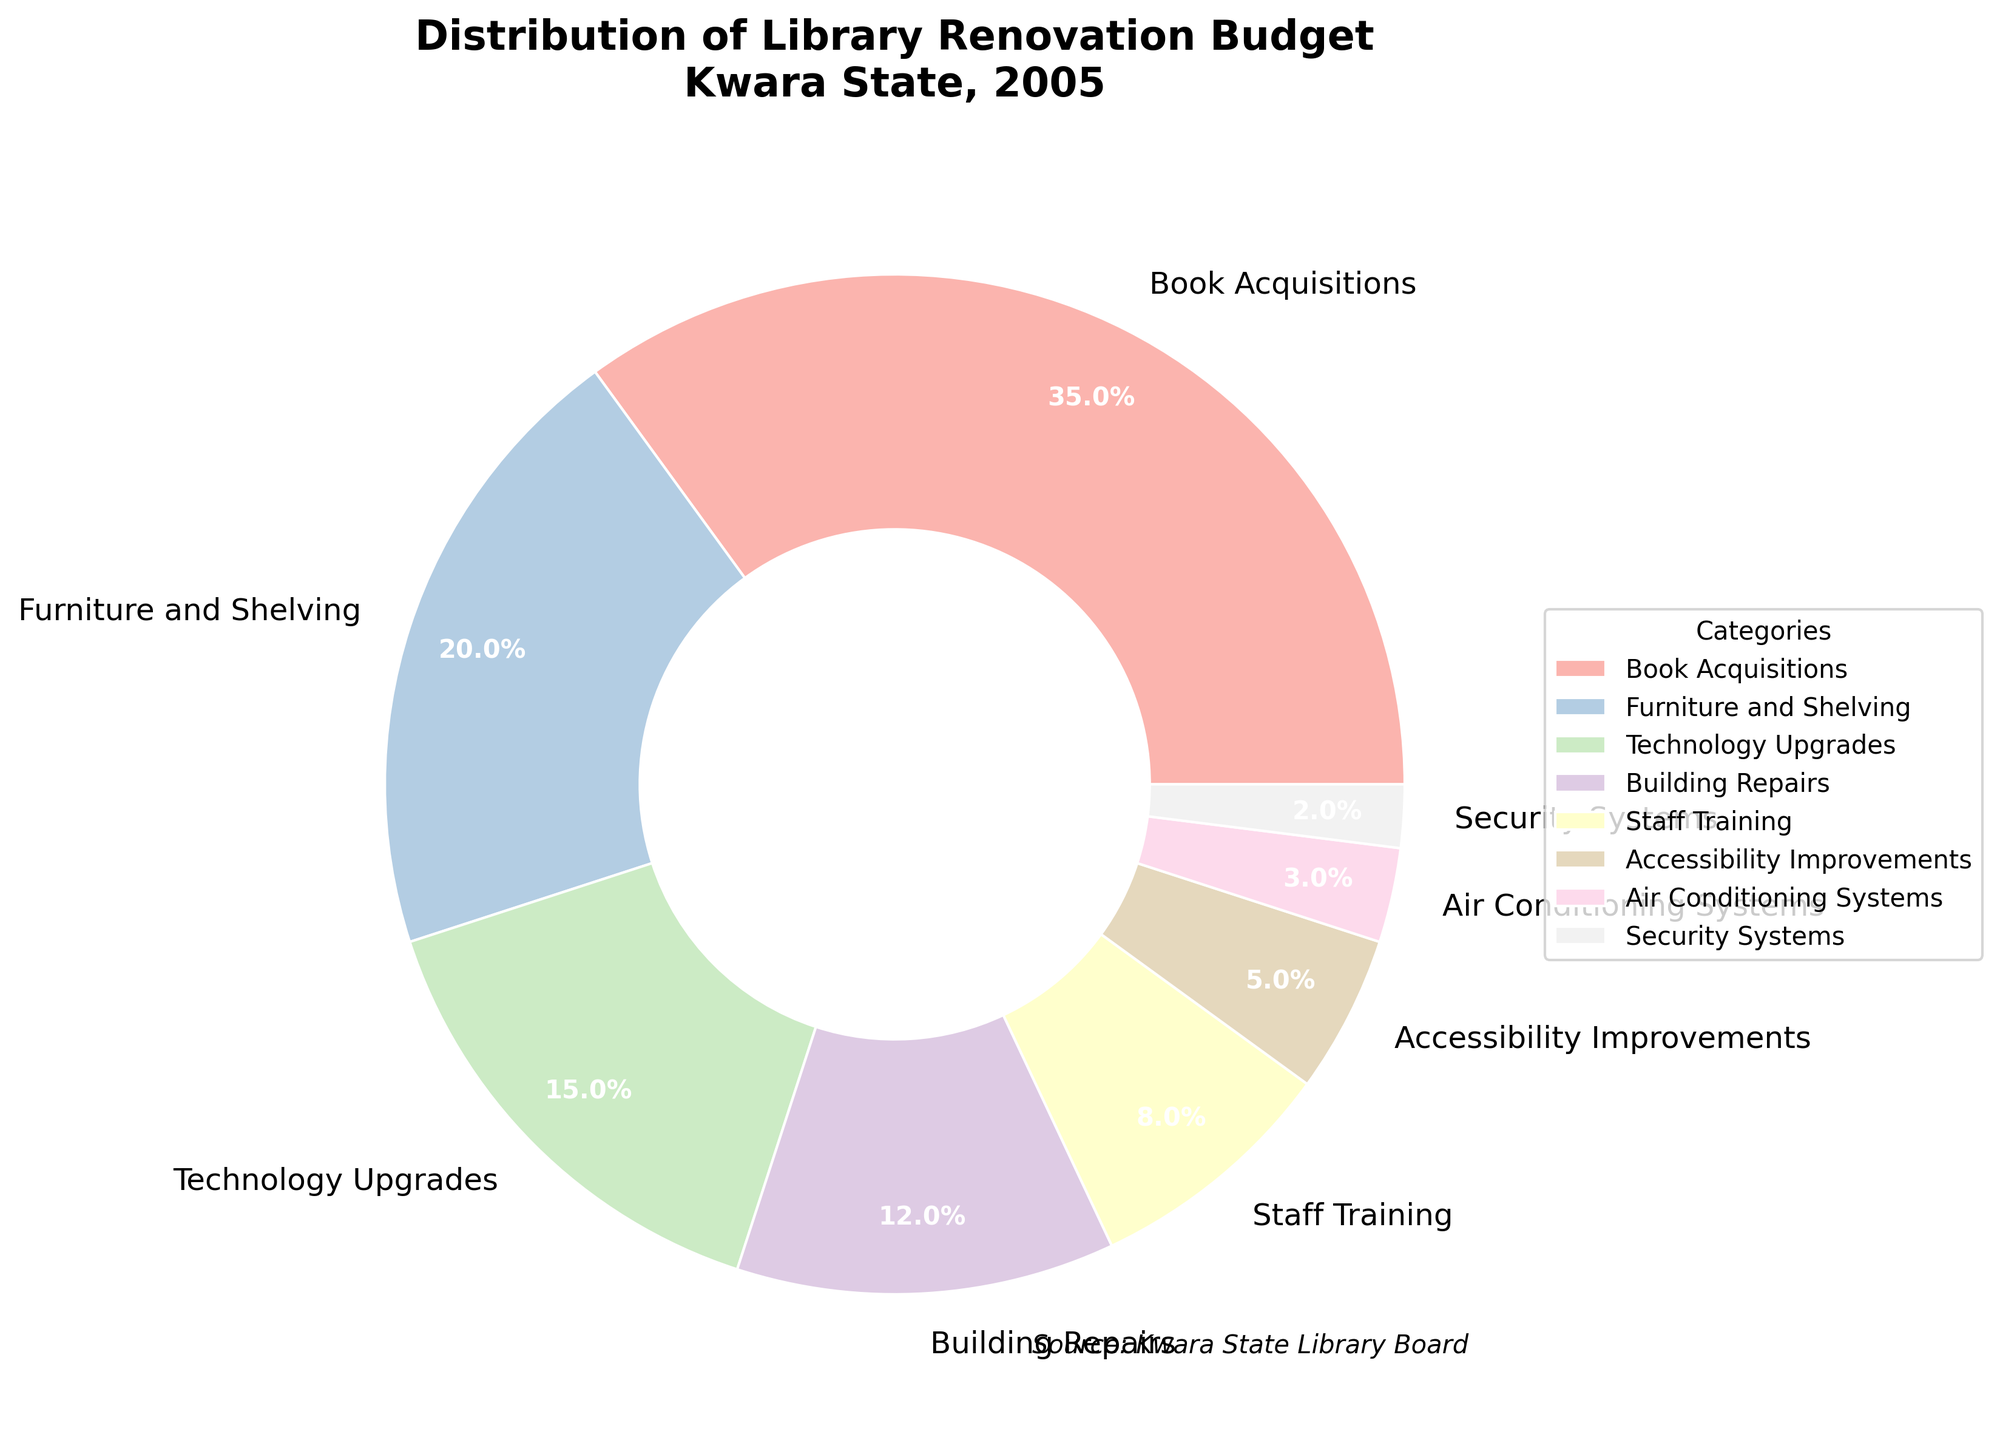What percentage of the budget was allocated to Book Acquisitions? From the pie chart, we see that the section labeled "Book Acquisitions" has a percentage value. Directly checking, we see it shows 35%.
Answer: 35% Which category received the smallest allocation? By looking at the pie chart, find the smallest wedge. The "Security Systems" wedge looks the smallest, marked at 2%.
Answer: Security Systems What is the combined budget percentage of Accessibility Improvements and Air Conditioning Systems? Find the percentages of Accessibility Improvements (5%) and Air Conditioning Systems (3%) from the chart. Add these values: 5% + 3% = 8%.
Answer: 8% Which category received more funding, Technology Upgrades or Furniture and Shelving? Identify the two wedges. Technology Upgrades is 15%, and Furniture and Shelving is 20%. Since 20% > 15%, Furniture and Shelving received more funding.
Answer: Furniture and Shelving What is the total budget percentage allocated to Staff Training and Building Repairs? Retrieve the percentages for Staff Training (8%) and Building Repairs (12%). Add them together: 8% + 12% = 20%.
Answer: 20% Are there more categories with less than 10% allocation or more than 10% allocation? Review the chart and count categories less than 10%: Accessibility Improvements, Air Conditioning Systems, and Security Systems (3). Count categories with more than 10%: Book Acquisitions, Furniture and Shelving, Technology Upgrades, Building Repairs, Staff Training (5). There are more categories with more than 10% allocation.
Answer: More than 10% Compare the allocations for Furniture and Shelving and Book Acquisitions. How much higher is Book Acquisitions? Check the values for both categories. Book Acquisitions is 35% and Furniture and Shelving is 20%. Calculate the difference: 35% - 20% = 15%.
Answer: 15% What is the combined percentage of the top three categories? Identify the top three categories by their allocations: Book Acquisitions (35%), Furniture and Shelving (20%), and Technology Upgrades (15%). Sum these percentages: 35% + 20% + 15% = 70%.
Answer: 70% If the total budget is 1,000,000 NGN, what is the budget amount for Accessibility Improvements? Accessibility Improvements have 5% allocation. Calculate 5% of 1,000,000 NGN: (5/100) * 1,000,000 = 50,000 NGN.
Answer: 50,000 NGN Which category is represented by the thickest wedge? The thickest wedge visually represents the largest allocation. In the chart, the thickest wedge is "Book Acquisitions" at 35%.
Answer: Book Acquisitions 